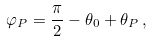Convert formula to latex. <formula><loc_0><loc_0><loc_500><loc_500>\varphi _ { P } = \frac { \pi } { 2 } - \theta _ { 0 } + \theta _ { P } \, ,</formula> 